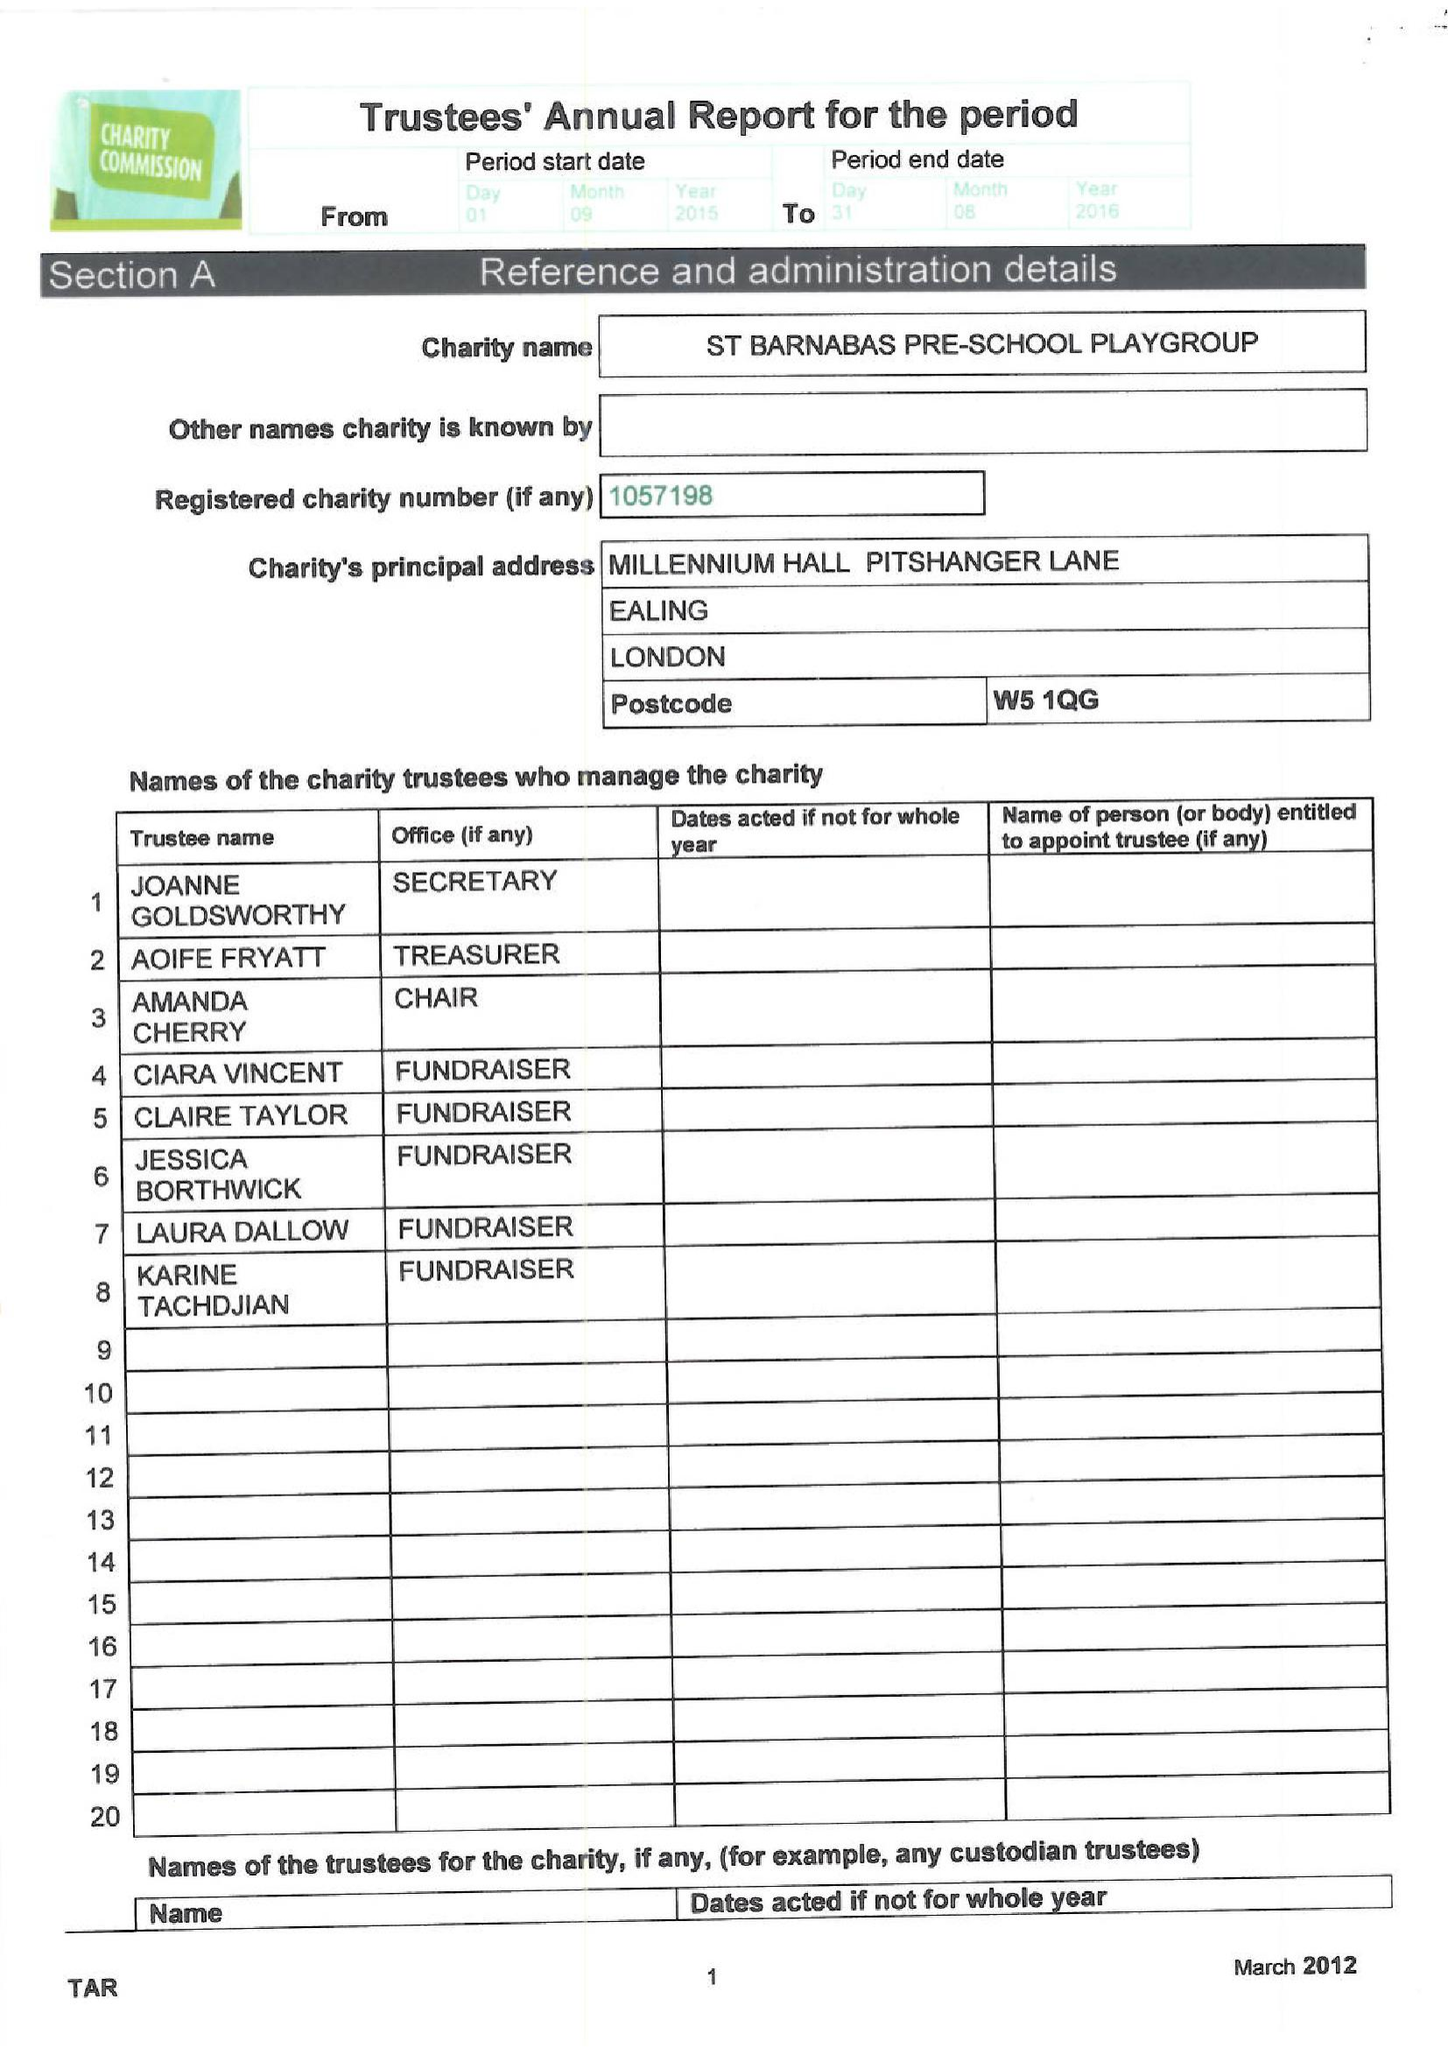What is the value for the address__post_town?
Answer the question using a single word or phrase. LONDON 